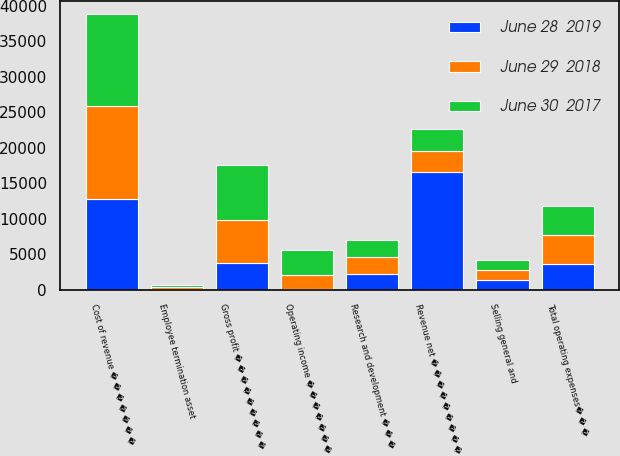<chart> <loc_0><loc_0><loc_500><loc_500><stacked_bar_chart><ecel><fcel>Revenue net � � � � � � � � �<fcel>Cost of revenue � � � � � � �<fcel>Gross profit � � � � � � � � �<fcel>Research and development � � �<fcel>Selling general and<fcel>Employee termination asset<fcel>Total operating expenses� � �<fcel>Operating income � � � � � � �<nl><fcel>June 28  2019<fcel>16569<fcel>12817<fcel>3752<fcel>2182<fcel>1317<fcel>166<fcel>3665<fcel>87<nl><fcel>June 30  2017<fcel>3029<fcel>12942<fcel>7705<fcel>2400<fcel>1473<fcel>215<fcel>4088<fcel>3617<nl><fcel>June 29  2018<fcel>3029<fcel>13021<fcel>6072<fcel>2441<fcel>1445<fcel>232<fcel>4118<fcel>1954<nl></chart> 